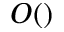Convert formula to latex. <formula><loc_0><loc_0><loc_500><loc_500>O ( )</formula> 